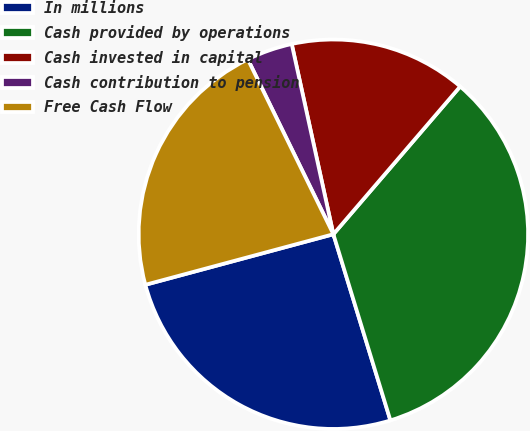Convert chart to OTSL. <chart><loc_0><loc_0><loc_500><loc_500><pie_chart><fcel>In millions<fcel>Cash provided by operations<fcel>Cash invested in capital<fcel>Cash contribution to pension<fcel>Free Cash Flow<nl><fcel>25.55%<fcel>33.98%<fcel>14.72%<fcel>3.81%<fcel>21.94%<nl></chart> 